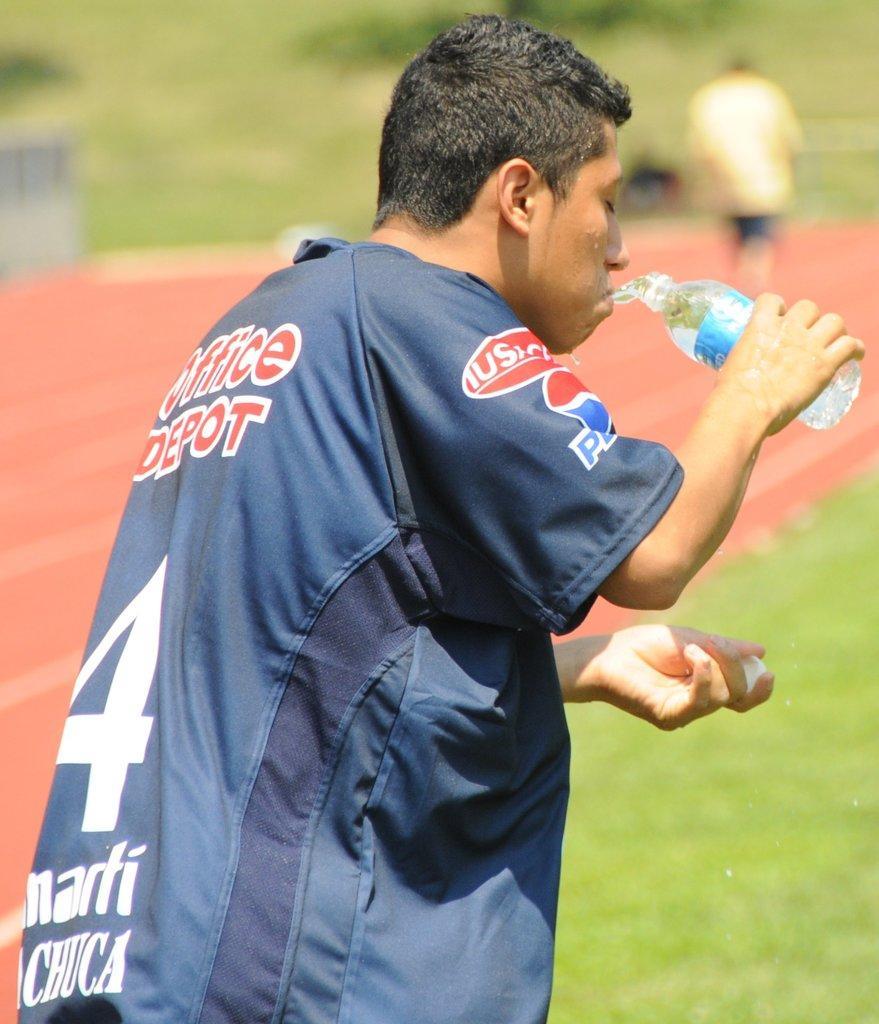Describe this image in one or two sentences. In this image we can see the person standing and holding a bottle and drinking water. And there is a blur background. 